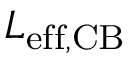<formula> <loc_0><loc_0><loc_500><loc_500>L _ { e f f , C B }</formula> 